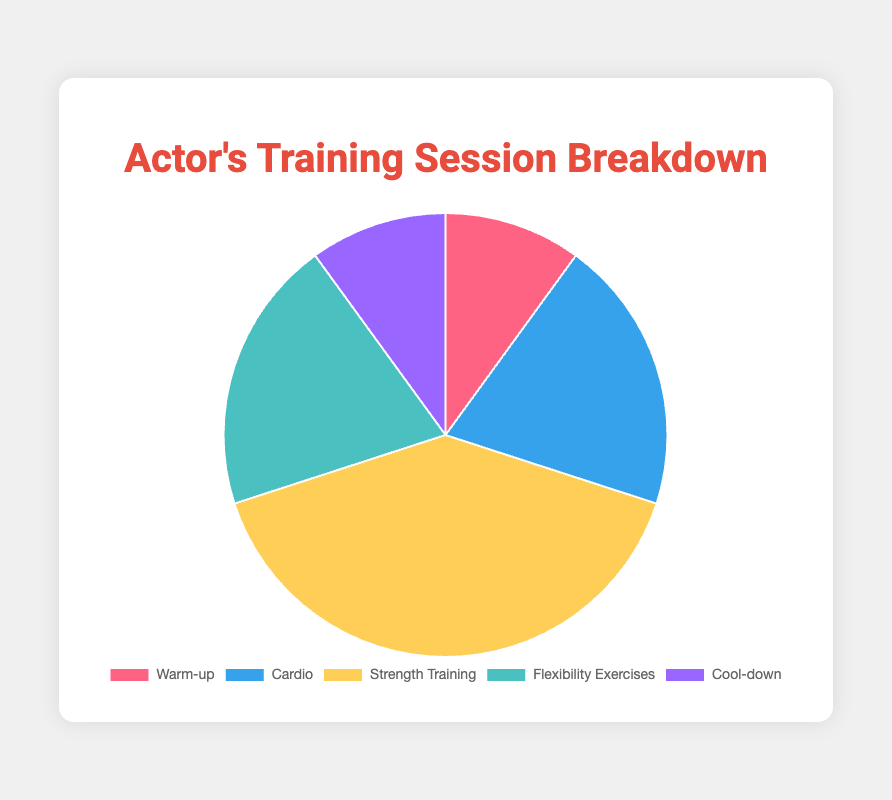Which activity takes up the most time in the training session? The activity with the highest duration percentage, Strength Training, takes up 40% of the time, which is the largest among all activities.
Answer: Strength Training What is the combined time allocation for Cardio and Flexibility Exercises? The duration percentages for Cardio and Flexibility Exercises are 20% and 20%, respectively. Adding these gives us 20% + 20% = 40%.
Answer: 40% How does the time allocated to the Warm-up compare to the Cool-down? Both Warm-up and Cool-down have the same duration percentage of 10%.
Answer: They are equal What percentage of the training session is allocated to activities other than Strength Training? Summing the percentages of Warm-up, Cardio, Flexibility Exercises, and Cool-down: 10% + 20% + 20% + 10% = 60%.
Answer: 60% Which activity accounts for half the time of Strength Training? Since Strength Training is 40%, looking for half of that leads us to 40% / 2 = 20%. Both Cardio and Flexibility Exercises are 20%.
Answer: Cardio and Flexibility Exercises What is the total time allocation for the Warm-up and Cool-down combined? The Warm-up and Cool-down both have percentages of 10%. Adding these gives us 10% + 10% = 20%.
Answer: 20% Between Cardio and Flexibility Exercises, which one takes up more time, or are they the same? Both Cardio and Flexibility Exercises have the same duration percentage of 20%.
Answer: They are equal How much more time is allocated to Strength Training compared to Cool-down? The duration percentage for Strength Training is 40% and for Cool-down is 10%. The difference is 40% - 10% = 30%.
Answer: 30% Visual attribute: Which activity is represented by the lightest color in the pie chart? The Cool-down activity is represented by the lightest purple color in the pie chart.
Answer: Cool-down 